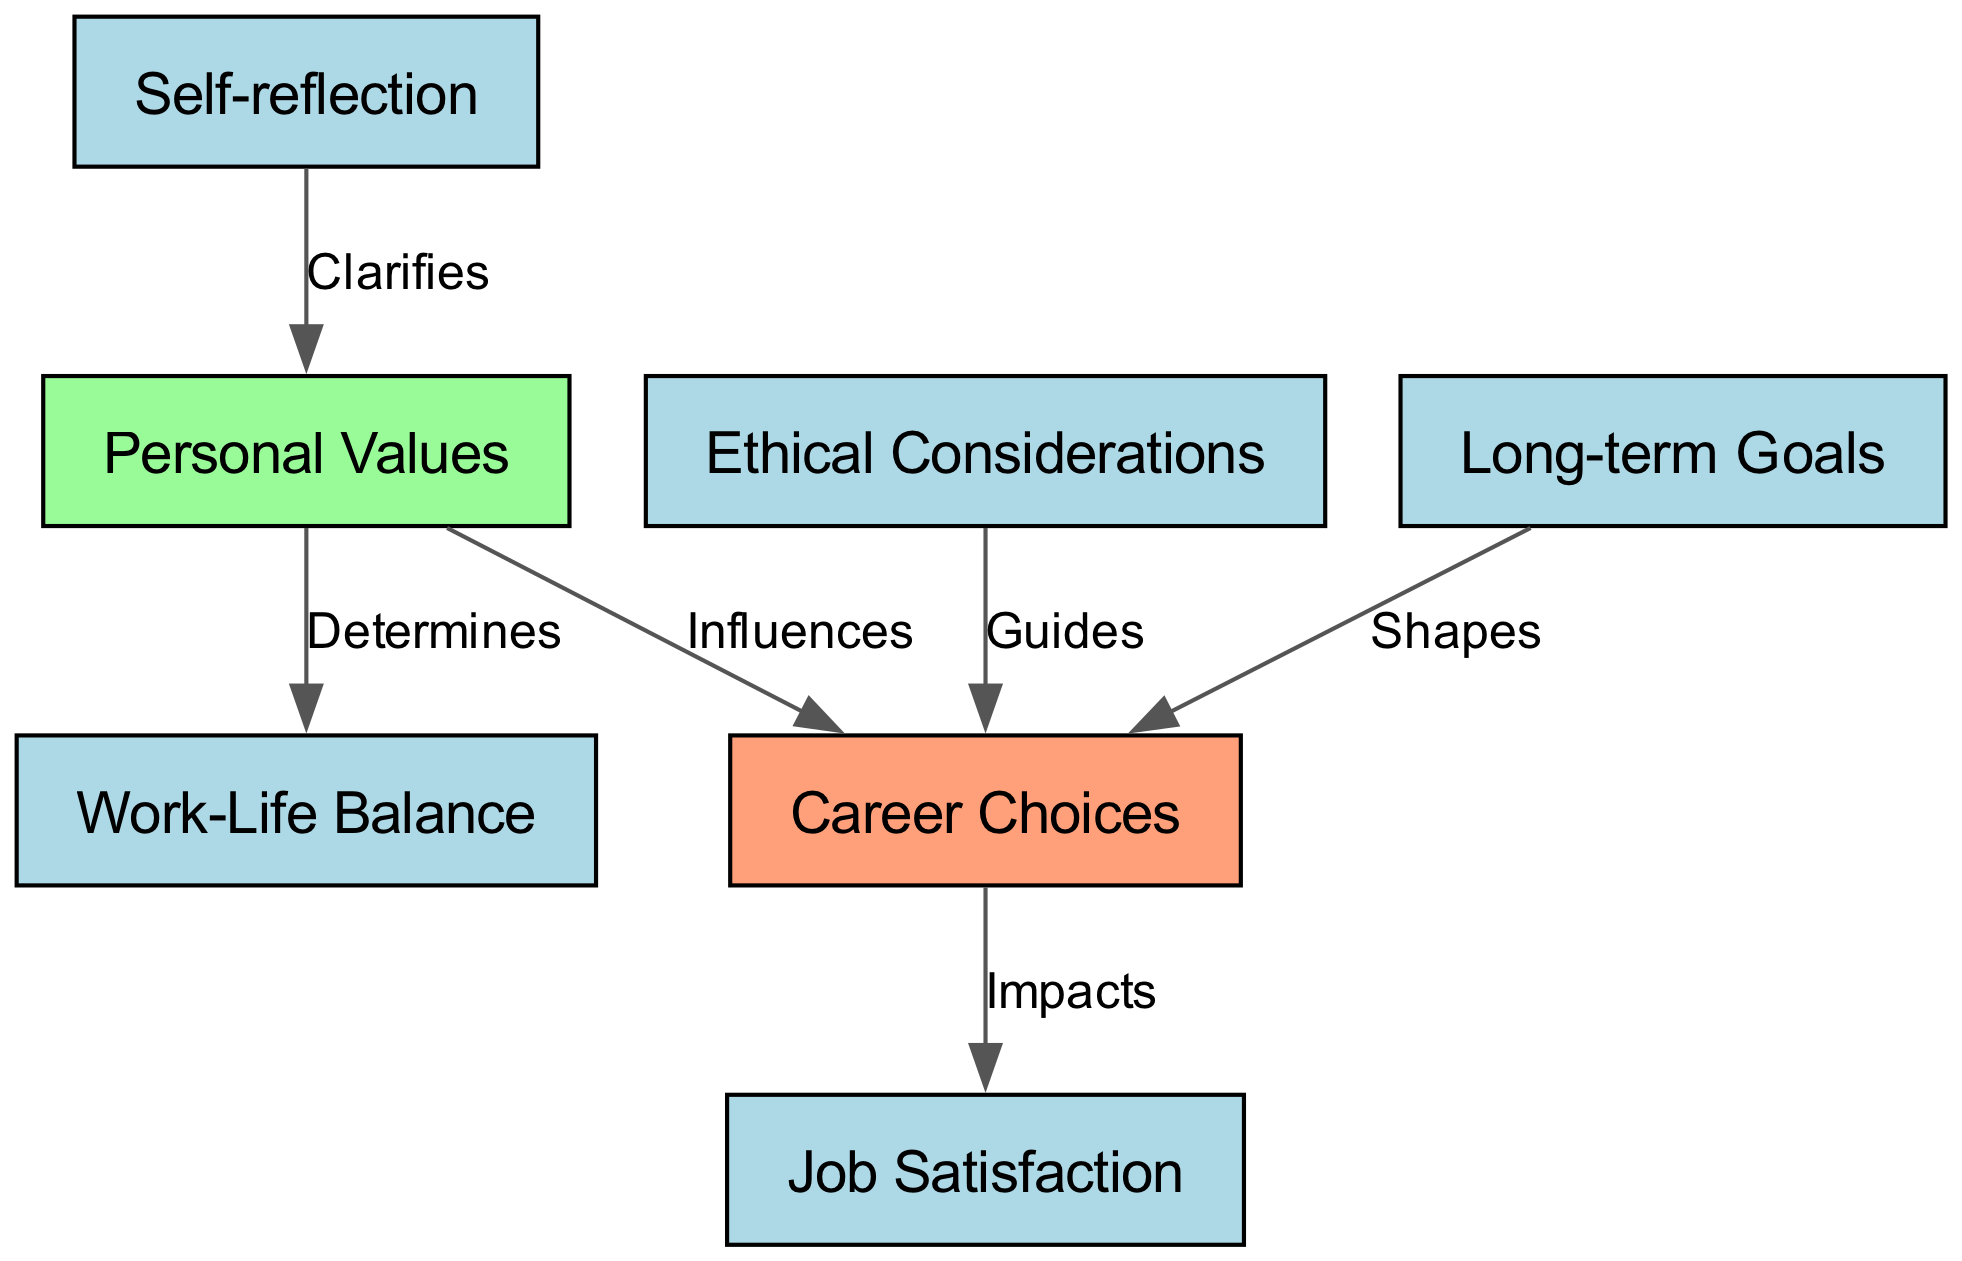What are the two main categories represented in the diagram? The diagram contains two main categories: "Career Choices" and "Personal Values." These are represented as the primary nodes from which other concepts branch out.
Answer: Career Choices, Personal Values How many nodes are present in the diagram? By counting the labeled nodes in the diagram, we find that there are a total of seven nodes: Career Choices, Personal Values, Self-reflection, Job Satisfaction, Work-Life Balance, Ethical Considerations, and Long-term Goals.
Answer: 7 What influence does personal values have on career choices? The edge connecting "Personal Values" to "Career Choices" is labeled "Influences," indicating that personal values are a driving factor in making career choices.
Answer: Influences Which node determines work-life balance? From the diagram, the edge from "Personal Values" to "Work-Life Balance" is labeled "Determines," showing that personal values play a crucial role in shaping an individual's work-life balance.
Answer: Personal Values What is the relationship between career choices and job satisfaction? The diagram shows an edge labeled "Impacts" from "Career Choices" to "Job Satisfaction," indicating that the choice of career has a direct effect on an individual's job satisfaction levels.
Answer: Impacts Which node clarifies personal values through self-reflection? The diagram indicates that "Self-reflection" is connected to "Personal Values" with the label "Clarifies," meaning self-reflection is essential for understanding and defining one's personal values.
Answer: Clarifies How does long-term goals affect career choices? The diagram illustrates that "Long-term Goals" shapes "Career Choices," showing that one's aspirations and future objectives influence the decisions made regarding careers.
Answer: Shapes What guides career choices according to the diagram? The edge labeled "Guides" connects "Ethical Considerations" to "Career Choices," which indicates that ethical considerations aid in guiding one's career decisions.
Answer: Guides 